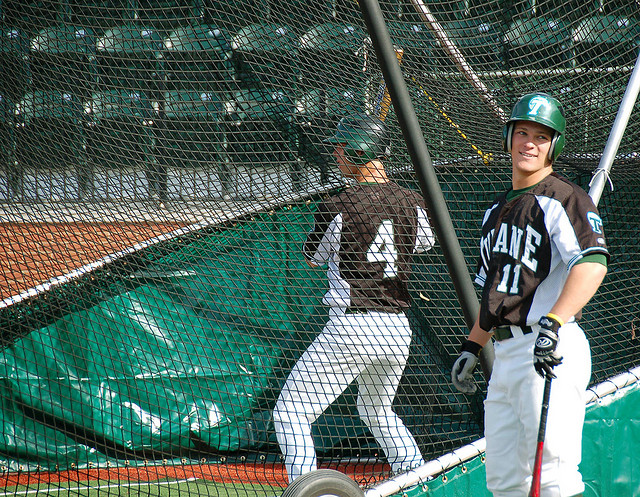Identify and read out the text in this image. 11 4 T 1 ANE 